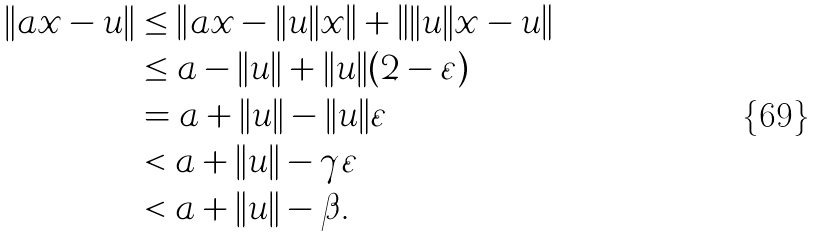Convert formula to latex. <formula><loc_0><loc_0><loc_500><loc_500>\| a x - u \| & \leq \left \| a x - \| u \| x \right \| + \left \| \| u \| x - u \right \| \\ & \leq a - \| u \| + \| u \| ( 2 - \varepsilon ) \\ & = a + \| u \| - \| u \| \varepsilon \\ & < a + \| u \| - \gamma \varepsilon \\ & < a + \| u \| - \beta .</formula> 